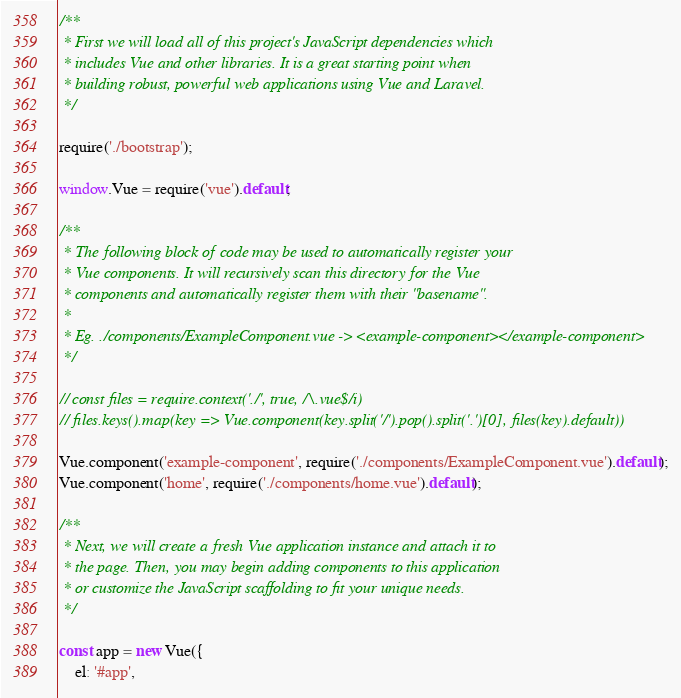<code> <loc_0><loc_0><loc_500><loc_500><_JavaScript_>/**
 * First we will load all of this project's JavaScript dependencies which
 * includes Vue and other libraries. It is a great starting point when
 * building robust, powerful web applications using Vue and Laravel.
 */

require('./bootstrap');

window.Vue = require('vue').default;

/**
 * The following block of code may be used to automatically register your
 * Vue components. It will recursively scan this directory for the Vue
 * components and automatically register them with their "basename".
 *
 * Eg. ./components/ExampleComponent.vue -> <example-component></example-component>
 */

// const files = require.context('./', true, /\.vue$/i)
// files.keys().map(key => Vue.component(key.split('/').pop().split('.')[0], files(key).default))

Vue.component('example-component', require('./components/ExampleComponent.vue').default);
Vue.component('home', require('./components/home.vue').default);

/**
 * Next, we will create a fresh Vue application instance and attach it to
 * the page. Then, you may begin adding components to this application
 * or customize the JavaScript scaffolding to fit your unique needs.
 */

const app = new Vue({
    el: '#app',</code> 